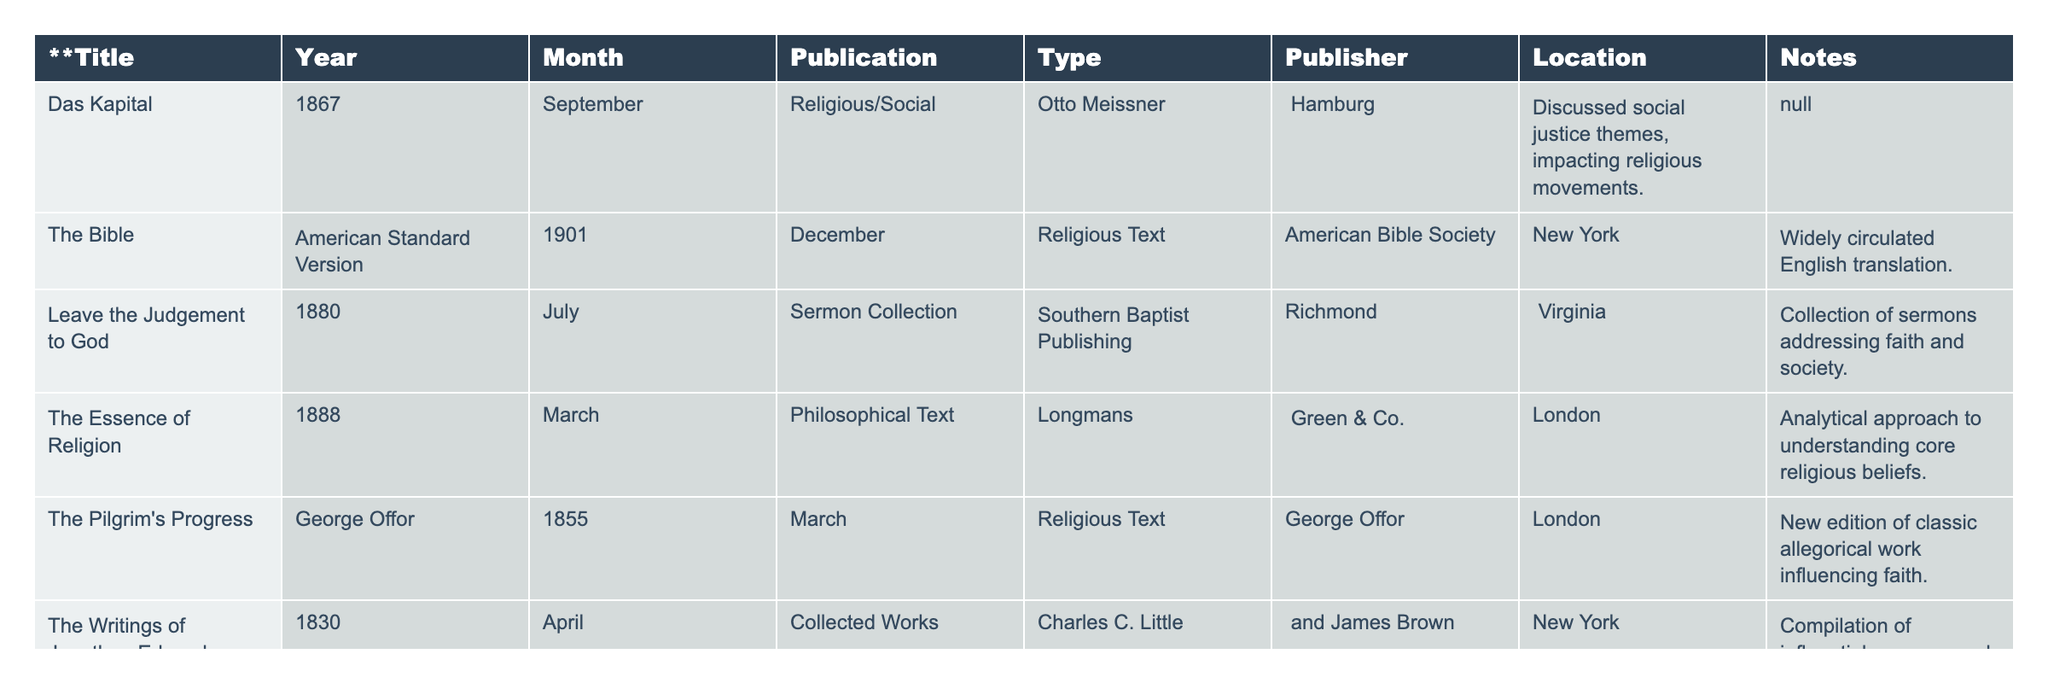What is the title of the sermon collection published in 1880? The table shows that the sermon collection published in 1880 is titled "Leave the Judgement to God."
Answer: Leave the Judgement to God Which publisher published "The Essence of Religion"? According to the table, "The Essence of Religion" was published by Longmans, Green & Co.
Answer: Longmans, Green & Co In which year was "Das Kapital" published? Referring to the table, "Das Kapital" was published in the year 1867.
Answer: 1867 What types of publications are found in the table? The table lists several types of publications, including Religious Text, Sermon Collection, Philosophical Text, and Collected Works.
Answer: Religious Text, Sermon Collection, Philosophical Text, Collected Works How many publications were released in the 1880s? The table lists three publications from the 1880s: "Leave the Judgement to God" (1880) and "The Essence of Religion" (1888). Therefore, there are 2 publications.
Answer: 2 Was "The Pilgrim's Progress" published before 1860? By checking the publication year in the table, "The Pilgrim's Progress" was published in 1855, which is before 1860.
Answer: Yes Which publication has the note referring to social justice themes? The table indicates that "Das Kapital" has a note discussing social justice themes.
Answer: Das Kapital Which publication originated from Richmond, Virginia? "Leave the Judgement to God" is noted in the table as being published in Richmond, Virginia.
Answer: Leave the Judgement to God Which was the earliest publication in the table? The earliest publication in the table is "The Writings of Jonathan Edwards," published in 1830.
Answer: The Writings of Jonathan Edwards What is the average publication year of the texts listed in the table? To find the average, sum the years (1867 + 1901 + 1880 + 1888 + 1855 + 1830 = 11111) and divide by the number of publications (6). The calculation gives an average year of about 1868.5, which rounds to 1869.
Answer: 1869 How many publications were published in London? The table shows that there are two publications from London: "The Essence of Religion" (1888) and "The Pilgrim's Progress" (1855).
Answer: 2 